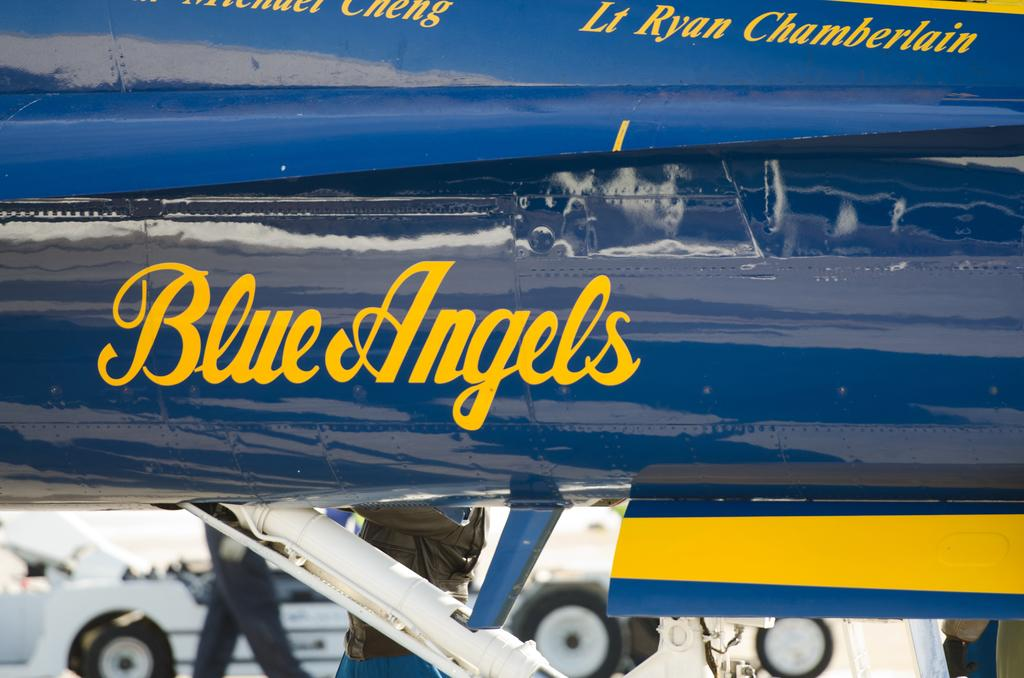Provide a one-sentence caption for the provided image. A close up of a Blue Angels Airplane logo with a person walking. 